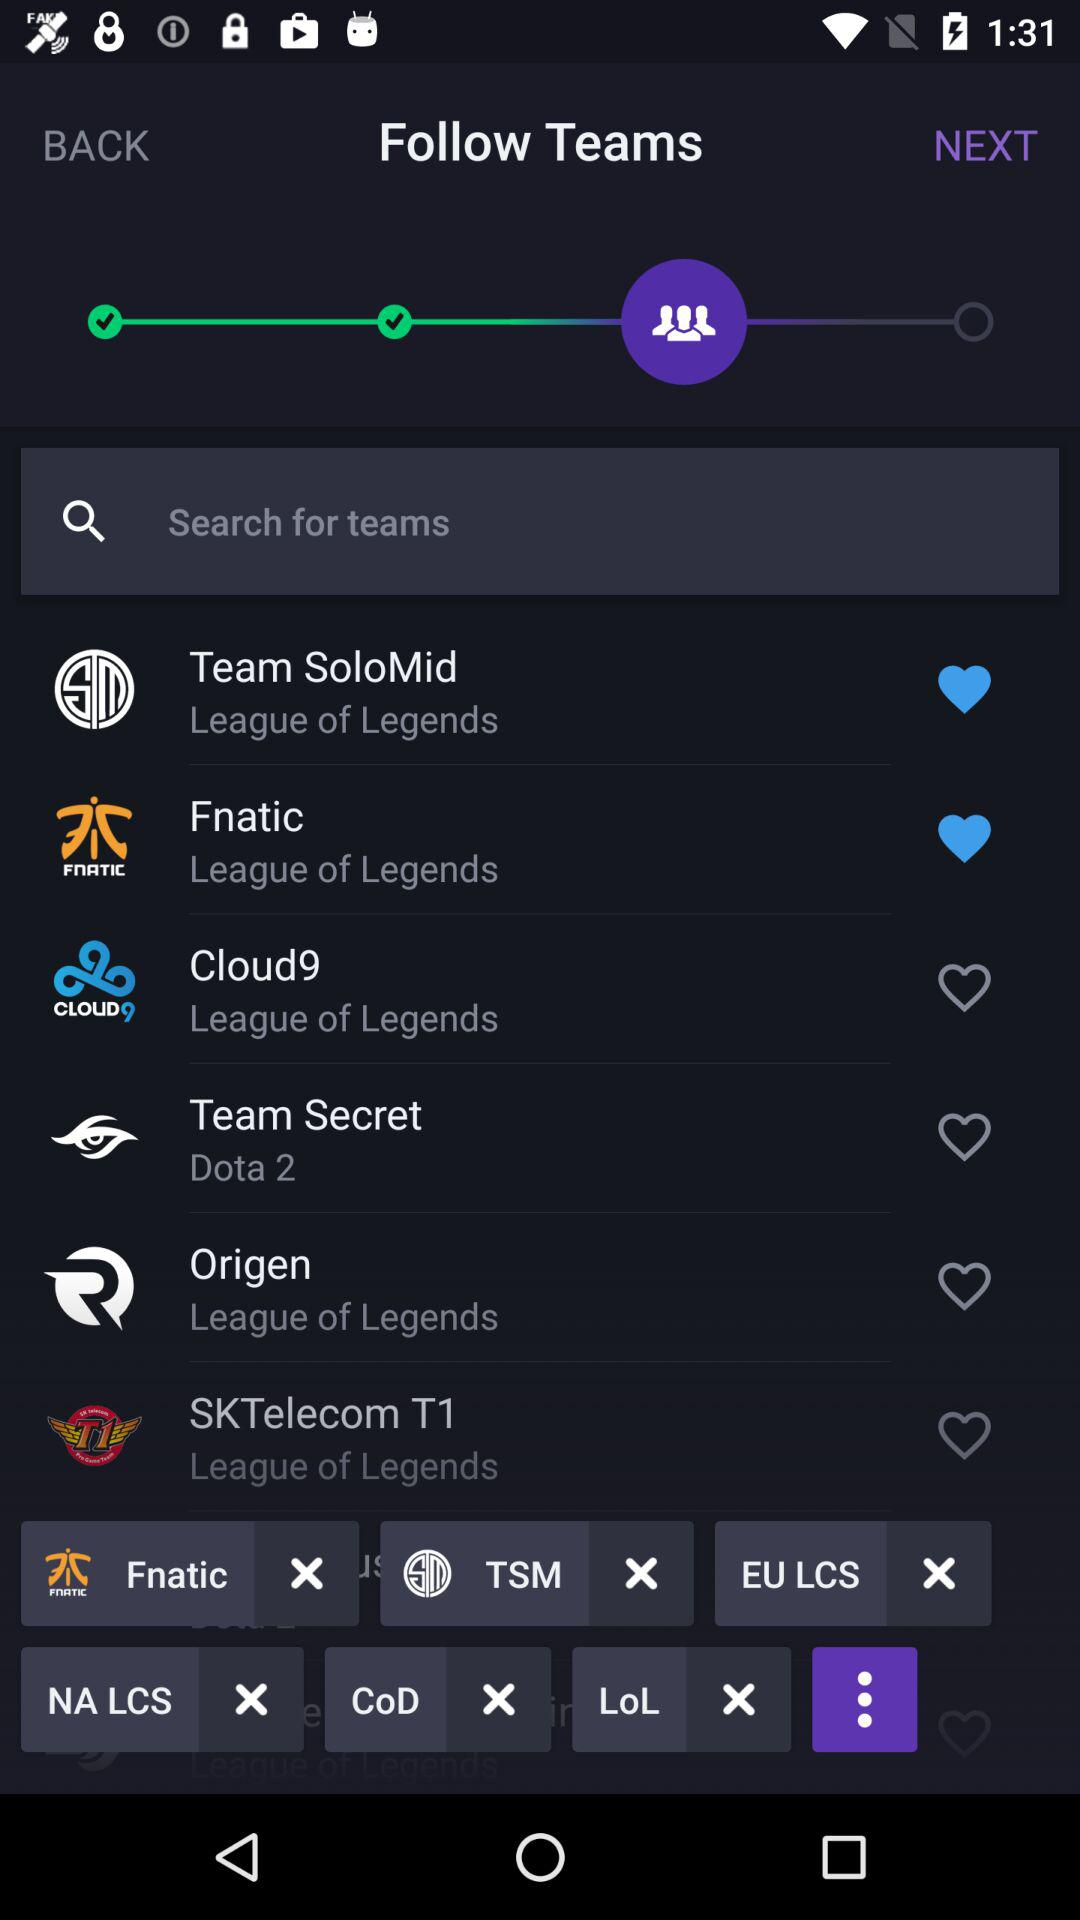Which teams are marked as favourites? The teams that are marked as favourites are "Team SoloMid" and "Fnatic". 